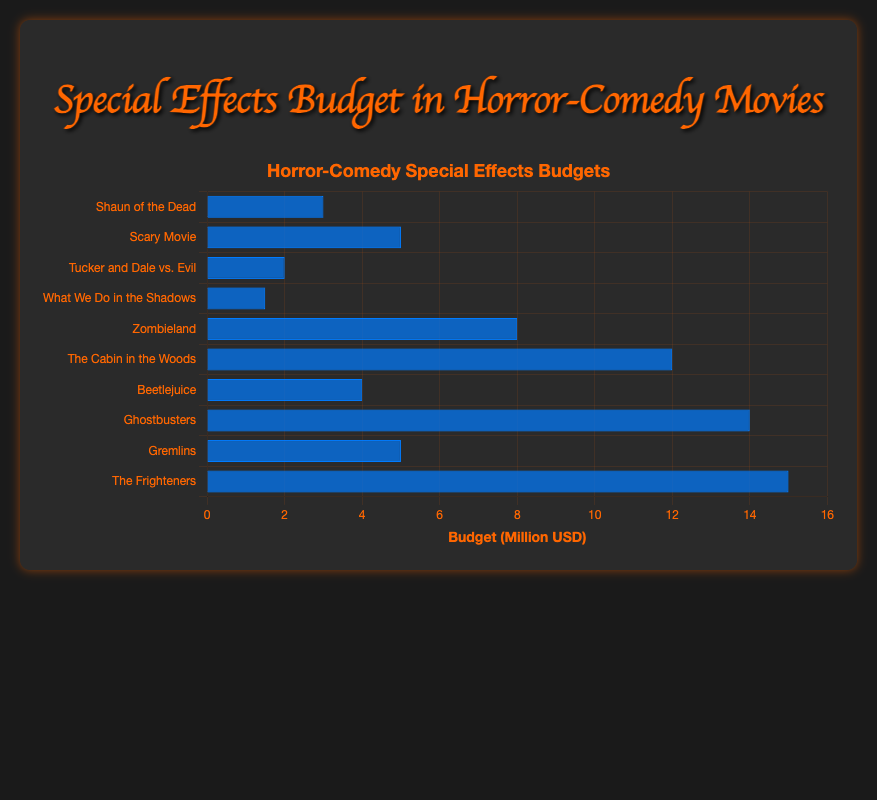Which movie has the highest special effects budget? By looking at the heights of the bars, the longest bar corresponds to the movie "The Frighteners" with a budget of 15 million USD.
Answer: The Frighteners Which movies have a special effects budget greater than 10 million USD? By inspecting the bars that extend beyond the 10 million USD mark, "The Cabin in the Woods," "Ghostbusters," and "The Frighteners" meet this criterion.
Answer: The Cabin in the Woods, Ghostbusters, The Frighteners What is the average special effects budget across all the movies? The total budget is the sum of all individual budgets (3 + 5 + 2 + 1.5 + 8 + 12 + 4 + 14 + 5 + 15 = 69.5). There are 10 movies, so the average is 69.5 / 10 = 6.95 million USD.
Answer: 6.95 million USD How much more is the budget of "Ghostbusters" compared to "What We Do in the Shadows"? The budget for "Ghostbusters" is 14 million USD and "What We Do in the Shadows" is 1.5 million USD, so the difference is 14 - 1.5 = 12.5 million USD.
Answer: 12.5 million USD What is the total special effects budget for "Scary Movie" and "Gremlins" combined? The special effects budgets for "Scary Movie" and "Gremlins" are 5 million USD each, so their combined budget is 5 + 5 = 10 million USD.
Answer: 10 million USD Which movie has the lowest special effects budget? The shortest bar corresponds to the movie "What We Do in the Shadows" with a budget of 1.5 million USD.
Answer: What We Do in the Shadows What's the difference between the largest and smallest special effects budgets? The largest budget is 15 million USD (The Frighteners), and the smallest is 1.5 million USD (What We Do in the Shadows). The difference is 15 - 1.5 = 13.5 million USD.
Answer: 13.5 million USD List the movies with a special effects budget equal to 5 million USD. By checking the bars that align with the 5 million USD mark, "Scary Movie" and "Gremlins" have budgets equal to 5 million USD.
Answer: Scary Movie, Gremlins What is the total special effects budget for all movies released in the 2000s? "Shaun of the Dead" (3) + "Scary Movie" (5) + "Tucker and Dale vs. Evil" (2) + "What We Do in the Shadows" (1.5) + "Zombieland" (8) + "The Cabin in the Woods" (12) = 31.5 million USD.
Answer: 31.5 million USD Which movie's special effects budget is closest to the median budget value? The sorted budgets are 1.5, 2, 3, 4, 5, 5, 8, 12, 14, 15 million USD. The median is the average of the 5th and 6th values (5 + 5) / 2 = 5 million USD. "Scary Movie" and "Gremlins" each have a budget of 5 million USD, closest to the median.
Answer: Scary Movie, Gremlins 